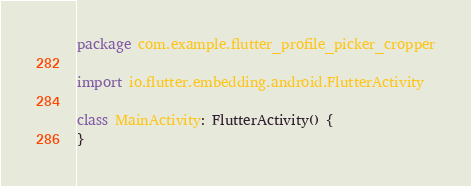<code> <loc_0><loc_0><loc_500><loc_500><_Kotlin_>package com.example.flutter_profile_picker_cropper

import io.flutter.embedding.android.FlutterActivity

class MainActivity: FlutterActivity() {
}
</code> 